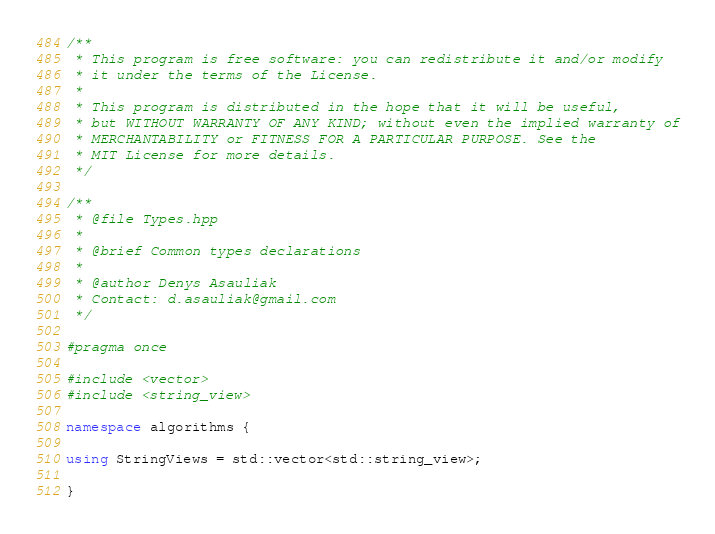Convert code to text. <code><loc_0><loc_0><loc_500><loc_500><_C++_>/**
 * This program is free software: you can redistribute it and/or modify
 * it under the terms of the License.
 *
 * This program is distributed in the hope that it will be useful,
 * but WITHOUT WARRANTY OF ANY KIND; without even the implied warranty of
 * MERCHANTABILITY or FITNESS FOR A PARTICULAR PURPOSE. See the
 * MIT License for more details.
 */

/**
 * @file Types.hpp
 *
 * @brief Common types declarations
 *
 * @author Denys Asauliak
 * Contact: d.asauliak@gmail.com
 */

#pragma once

#include <vector>
#include <string_view>

namespace algorithms {

using StringViews = std::vector<std::string_view>;

}</code> 